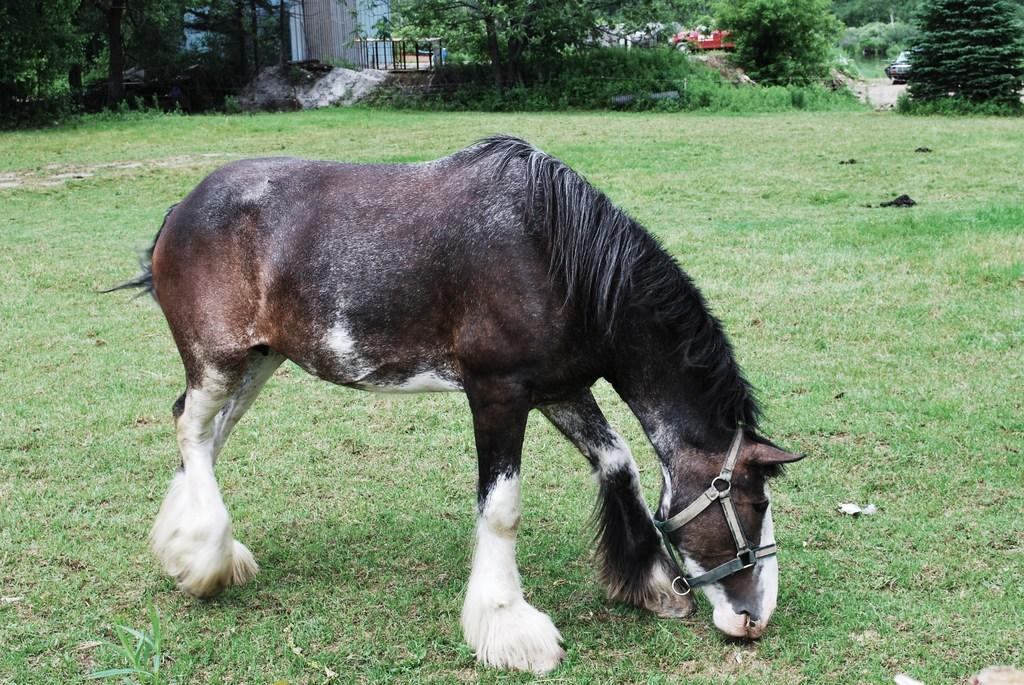What animal is standing in the image? There is a horse standing in the image. What type of vegetation is at the bottom of the image? Grass is present at the bottom of the image. What can be seen in the background of the image? There are trees in the background of the image. What type of man-made object is visible in the image? There is a vehicle visible in the image. What color is the scarf worn by the aunt in the image? There is no scarf or aunt present in the image. What type of creature is standing near the scarecrow in the image? There is no scarecrow present in the image, and therefore no creature standing near it. 